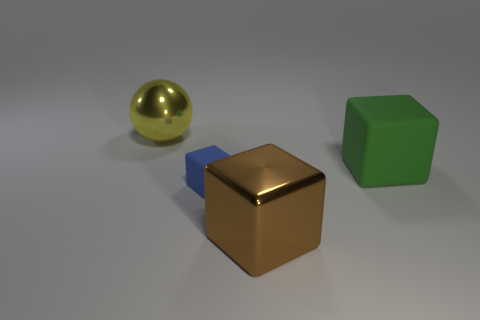What material is the big brown object that is the same shape as the small blue matte object?
Your answer should be very brief. Metal. Do the large thing that is to the left of the large brown thing and the tiny rubber object have the same shape?
Ensure brevity in your answer.  No. What material is the big cube to the right of the brown shiny object?
Your answer should be compact. Rubber. How many other tiny objects have the same shape as the tiny object?
Your response must be concise. 0. What material is the large object that is on the left side of the large metallic thing in front of the blue cube made of?
Make the answer very short. Metal. Is there a cube made of the same material as the yellow thing?
Provide a short and direct response. Yes. There is a green matte thing; what shape is it?
Your response must be concise. Cube. How many metal blocks are there?
Your response must be concise. 1. What is the color of the metallic object that is on the left side of the rubber cube that is to the left of the brown cube?
Keep it short and to the point. Yellow. There is a metal ball that is the same size as the green matte thing; what color is it?
Your answer should be compact. Yellow. 